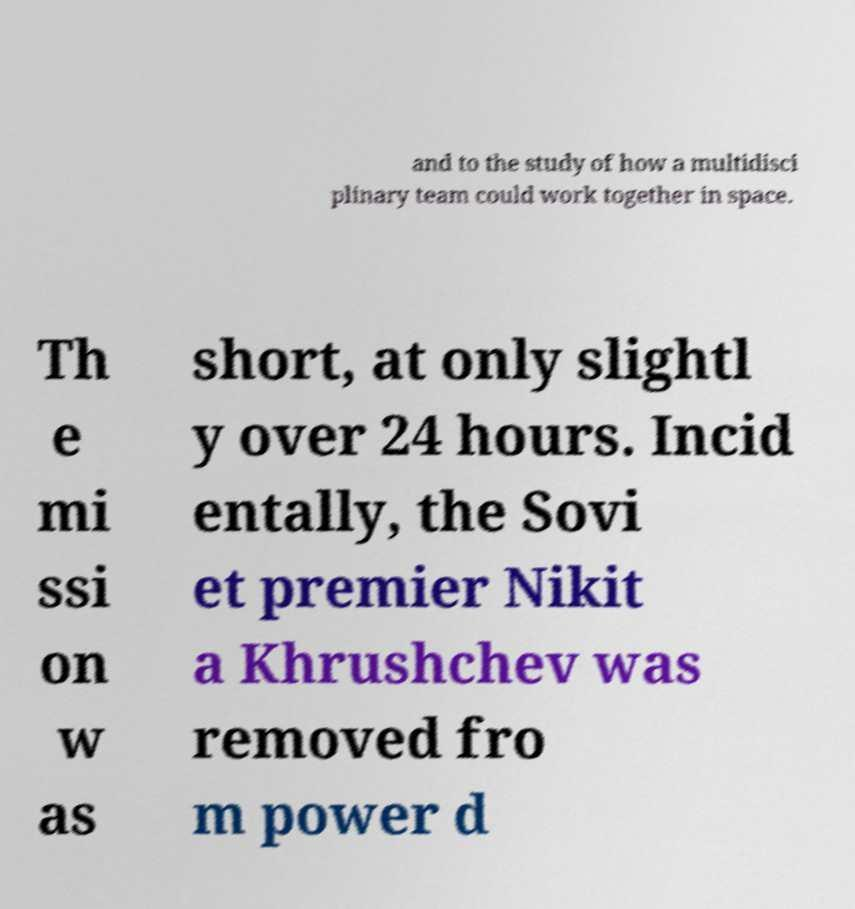Please identify and transcribe the text found in this image. and to the study of how a multidisci plinary team could work together in space. Th e mi ssi on w as short, at only slightl y over 24 hours. Incid entally, the Sovi et premier Nikit a Khrushchev was removed fro m power d 